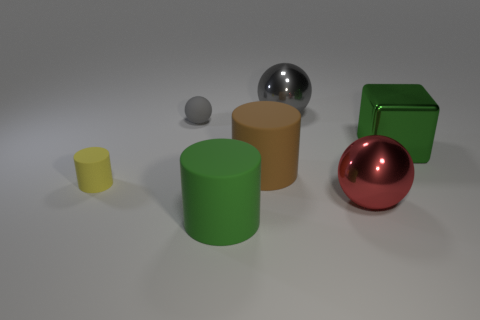Subtract all tiny rubber balls. How many balls are left? 2 Subtract all yellow cylinders. How many gray balls are left? 2 Add 2 big brown metallic spheres. How many objects exist? 9 Subtract all spheres. How many objects are left? 4 Subtract all brown cylinders. How many cylinders are left? 2 Subtract 2 balls. How many balls are left? 1 Subtract all cyan balls. Subtract all green blocks. How many balls are left? 3 Subtract all large gray rubber spheres. Subtract all small cylinders. How many objects are left? 6 Add 3 shiny things. How many shiny things are left? 6 Add 2 tiny rubber spheres. How many tiny rubber spheres exist? 3 